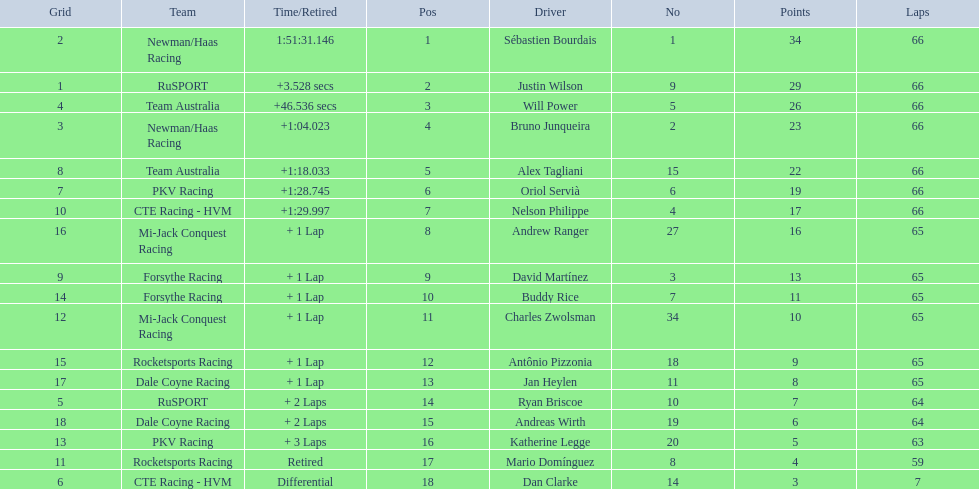How many laps did oriol servia complete at the 2006 gran premio? 66. How many laps did katherine legge complete at the 2006 gran premio? 63. Between servia and legge, who completed more laps? Oriol Servià. 